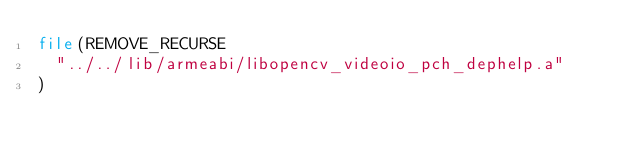Convert code to text. <code><loc_0><loc_0><loc_500><loc_500><_CMake_>file(REMOVE_RECURSE
  "../../lib/armeabi/libopencv_videoio_pch_dephelp.a"
)
</code> 